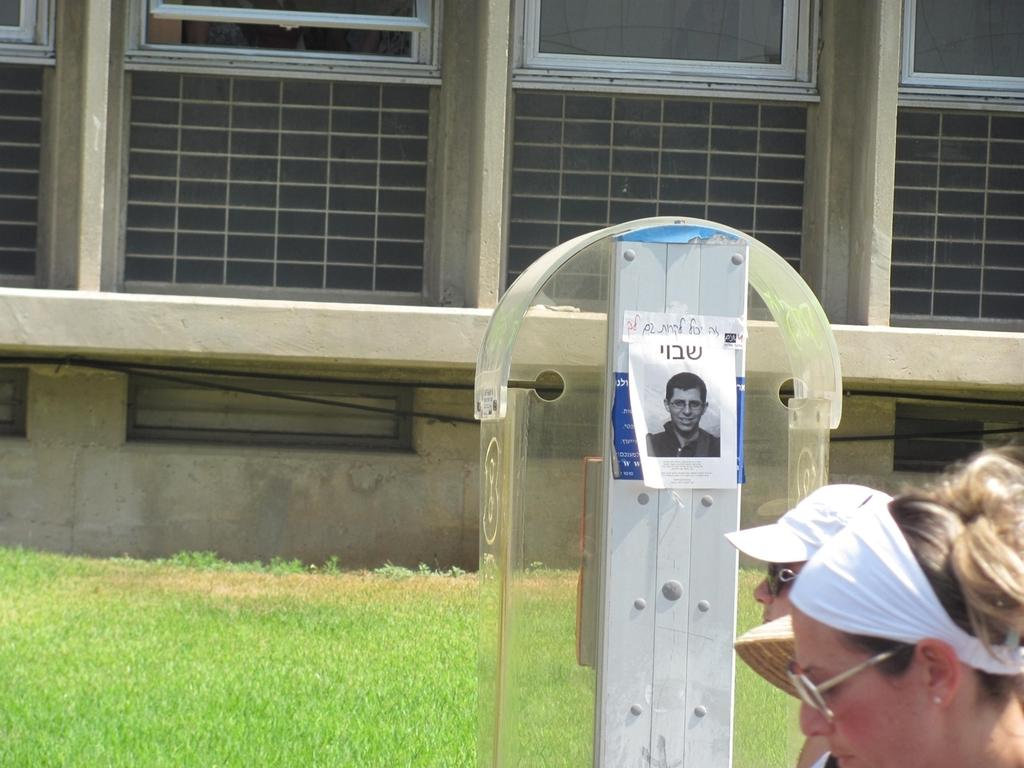Who or what can be seen in the image? There are people in the image. What is the object with posts attached to it in the image? The object with posts attached to it is not specified in the facts provided. What type of natural environment is visible in the background of the image? There is grass visible in the background of the image. What type of man-made structure is visible in the background of the image? There is a wall with windows visible in the background of the image. What type of patch is being used to fix the drain in the image? There is no drain or patch present in the image. 